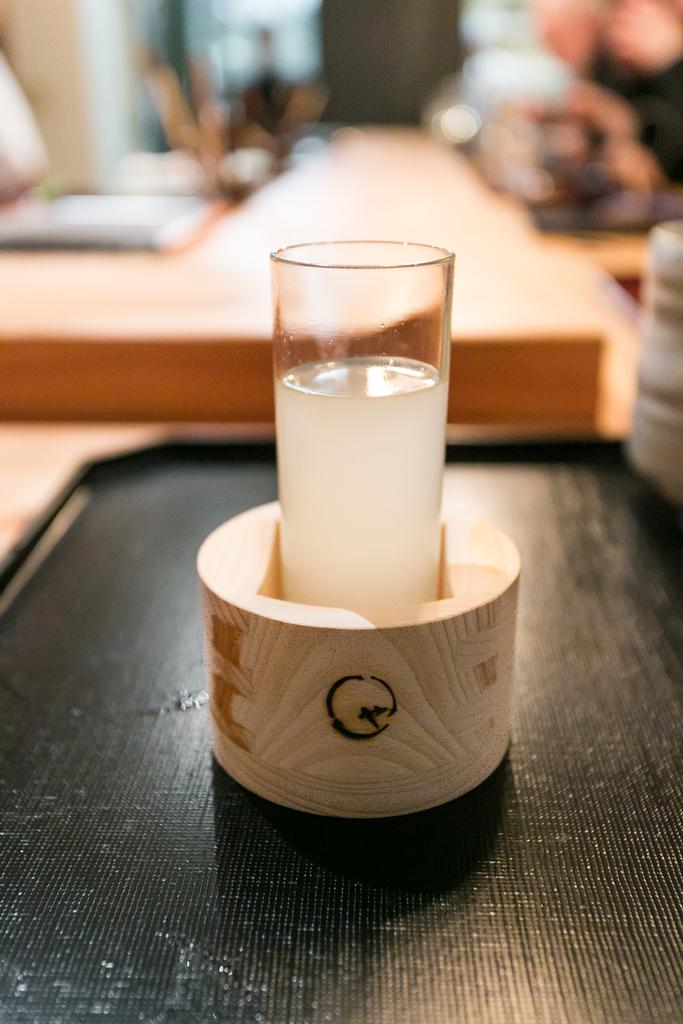What is inside the glass that is visible in the image? There is a glass with liquid in the image. Where is the glass placed? The glass is placed in a black tray. What is the tray resting on? The black tray is on a wooden table. Can you describe the background of the image? The background of the image is blurred. How many jellyfish are swimming in the liquid inside the glass? There are no jellyfish present in the image; it is a glass with liquid. What type of smile can be seen on the wooden table in the image? There is no smile present in the image, as it features a glass with liquid, a black tray, and a wooden table. 